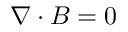<formula> <loc_0><loc_0><loc_500><loc_500>{ \nabla } \cdot { B } = 0</formula> 